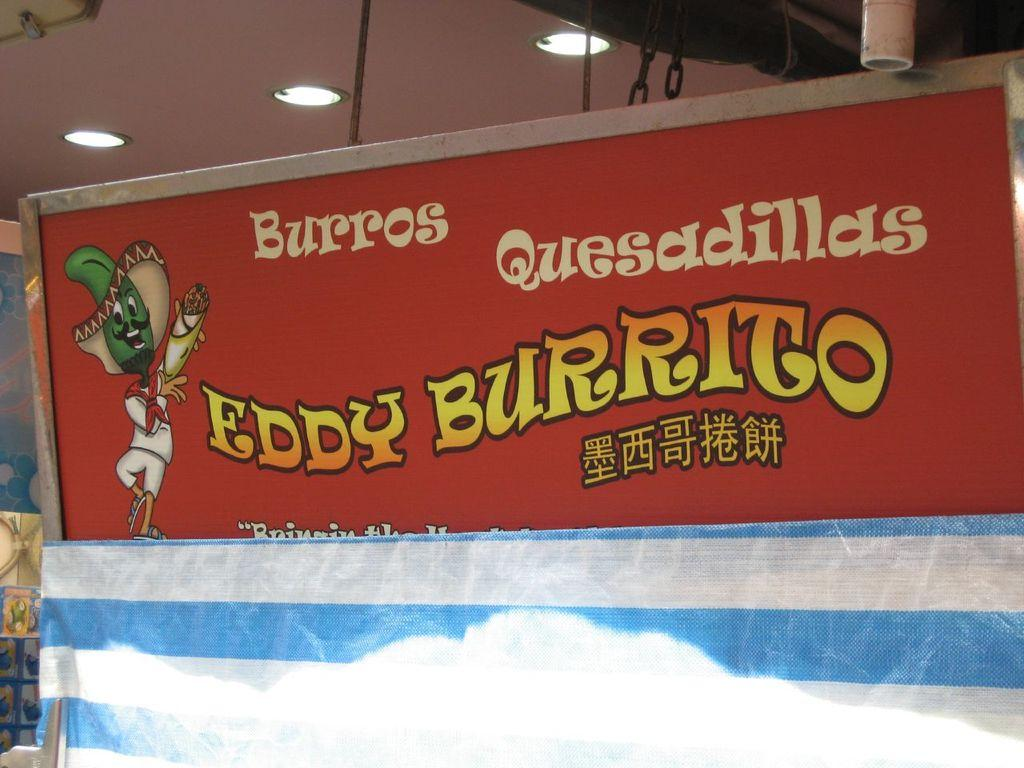<image>
Give a short and clear explanation of the subsequent image. Eddy burrito sign that sells burritos and quesadillas 